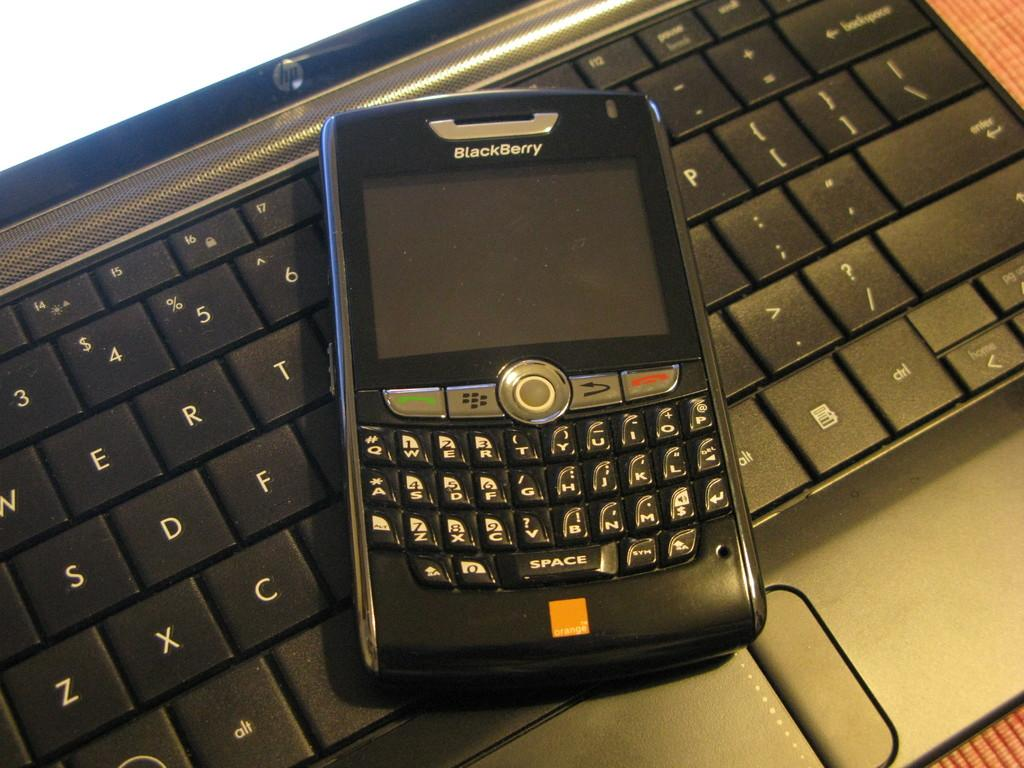<image>
Share a concise interpretation of the image provided. A powered down blackberyy branded device sitting on top of a keyboard. 